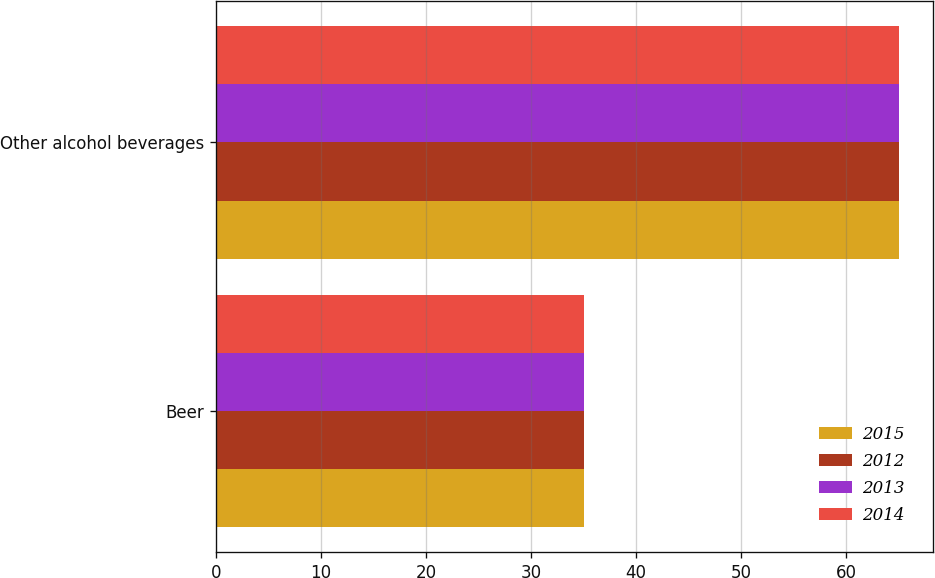<chart> <loc_0><loc_0><loc_500><loc_500><stacked_bar_chart><ecel><fcel>Beer<fcel>Other alcohol beverages<nl><fcel>2015<fcel>35<fcel>65<nl><fcel>2012<fcel>35<fcel>65<nl><fcel>2013<fcel>35<fcel>65<nl><fcel>2014<fcel>35<fcel>65<nl></chart> 